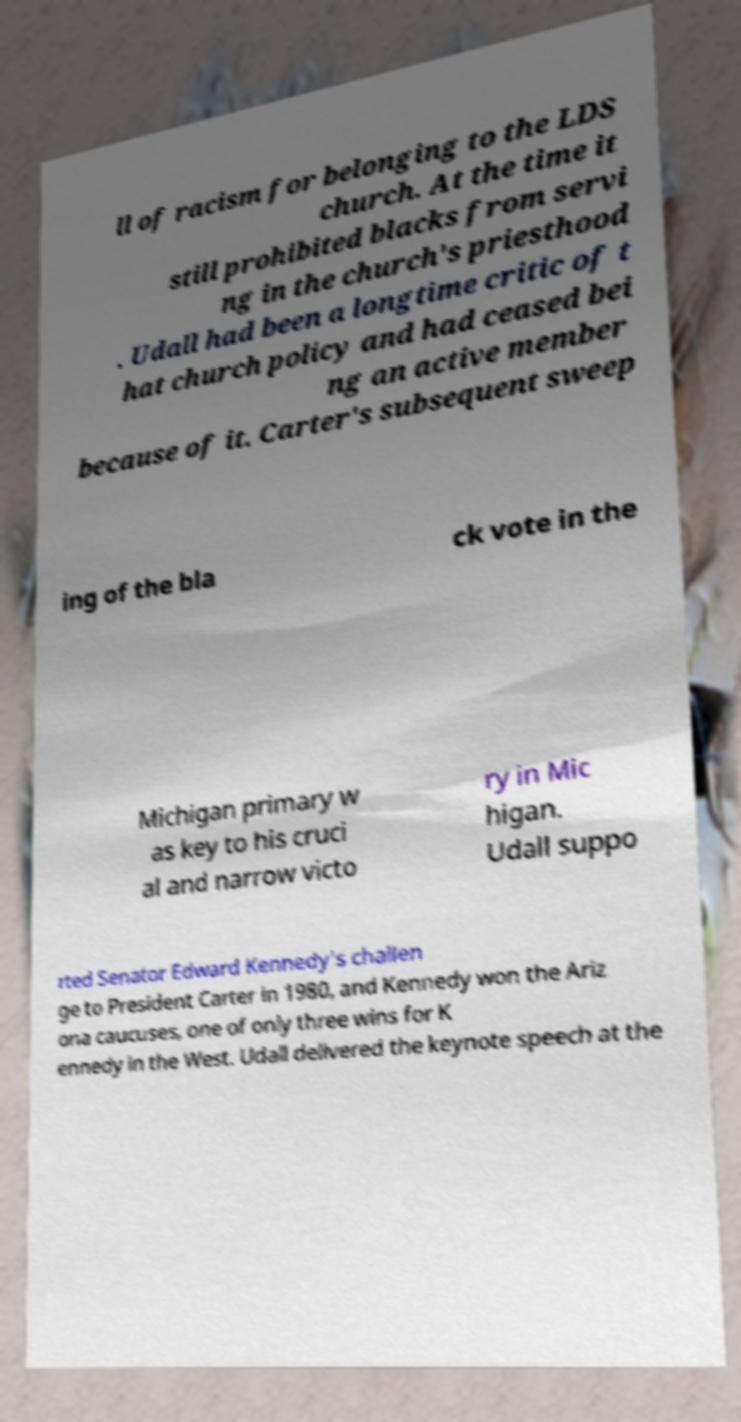I need the written content from this picture converted into text. Can you do that? ll of racism for belonging to the LDS church. At the time it still prohibited blacks from servi ng in the church's priesthood . Udall had been a longtime critic of t hat church policy and had ceased bei ng an active member because of it. Carter's subsequent sweep ing of the bla ck vote in the Michigan primary w as key to his cruci al and narrow victo ry in Mic higan. Udall suppo rted Senator Edward Kennedy's challen ge to President Carter in 1980, and Kennedy won the Ariz ona caucuses, one of only three wins for K ennedy in the West. Udall delivered the keynote speech at the 